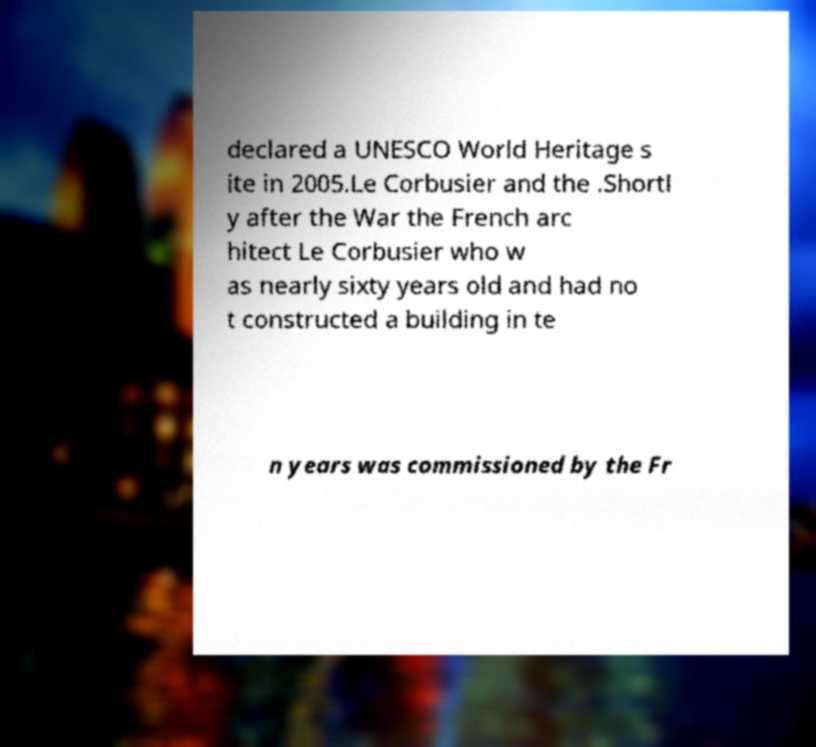Could you extract and type out the text from this image? declared a UNESCO World Heritage s ite in 2005.Le Corbusier and the .Shortl y after the War the French arc hitect Le Corbusier who w as nearly sixty years old and had no t constructed a building in te n years was commissioned by the Fr 